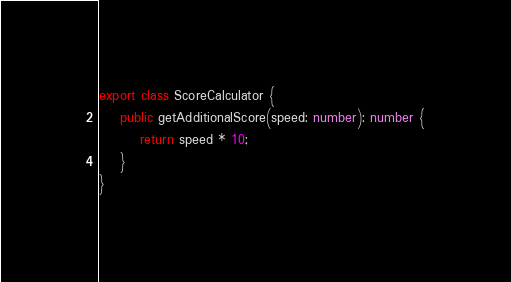<code> <loc_0><loc_0><loc_500><loc_500><_TypeScript_>export class ScoreCalculator {
    public getAdditionalScore(speed: number): number {
        return speed * 10;
    }
}
</code> 